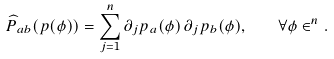<formula> <loc_0><loc_0><loc_500><loc_500>\widehat { P } _ { a b } ( p ( \phi ) ) = \sum _ { j = 1 } ^ { n } \partial _ { j } p _ { a } ( \phi ) \, \partial _ { j } p _ { b } ( \phi ) , \quad \forall \phi \in \real ^ { n } .</formula> 